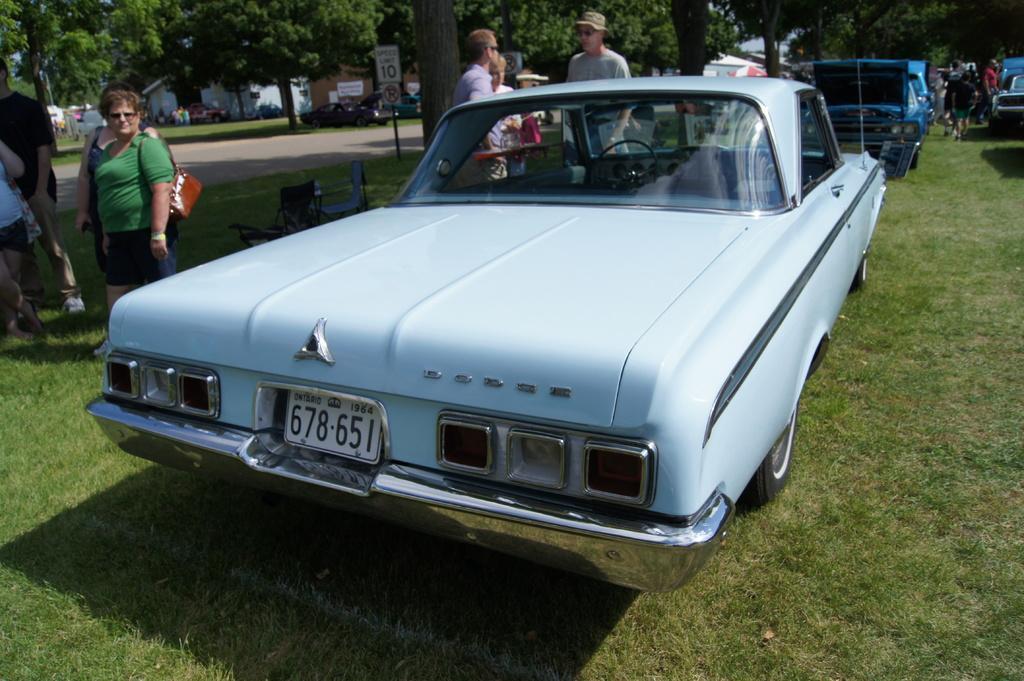Can you describe this image briefly? In this image in the front there is a car with some numbers written on it. In the center there are persons standing. In the background there are trees, persons, vehicles, buildings and boards with some text written on it. In the center there are empty chairs. In the front there's grass on the ground. 